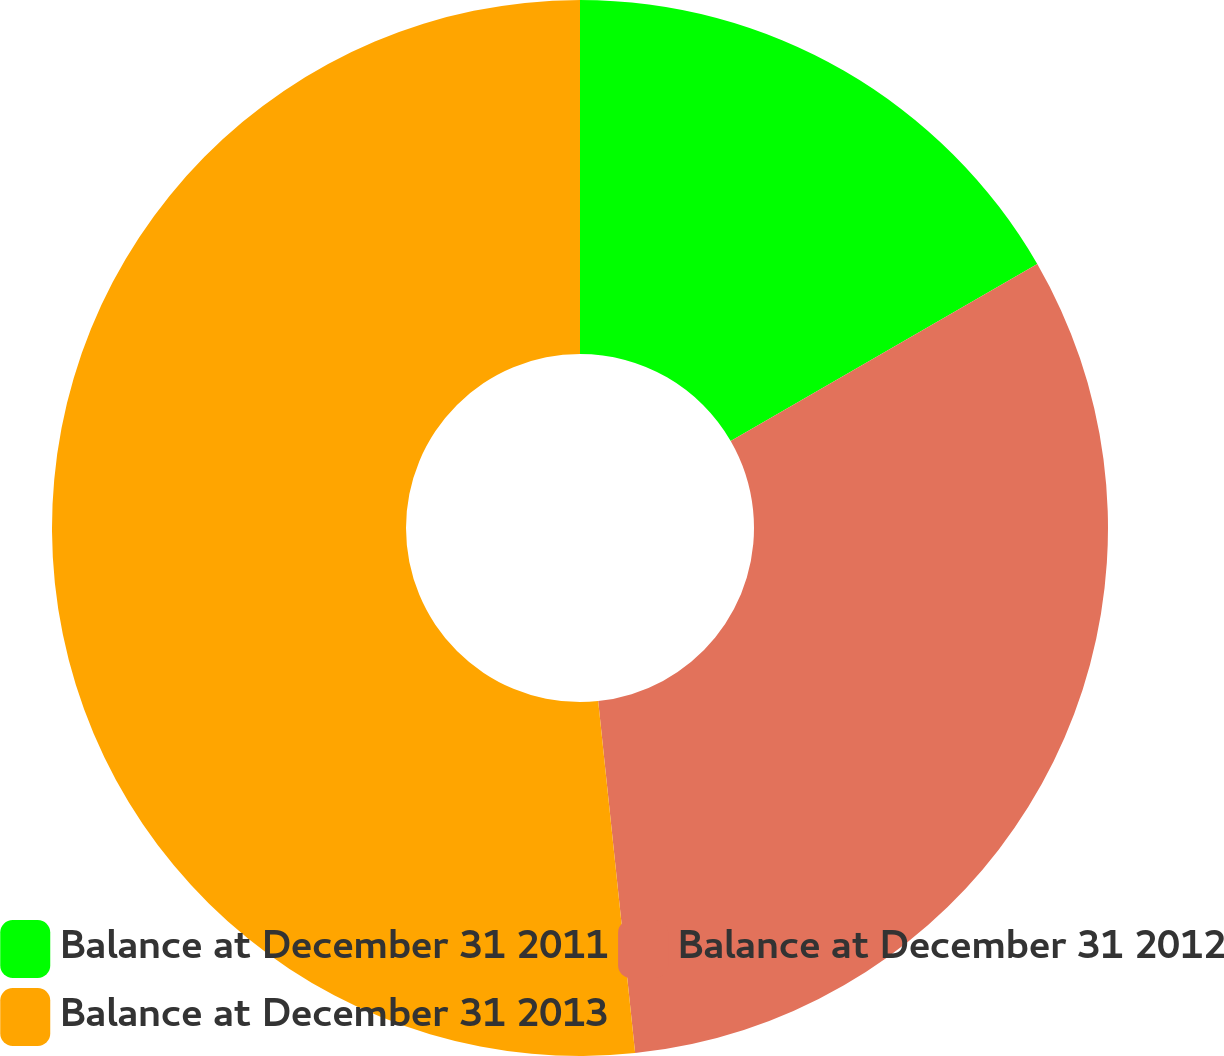Convert chart to OTSL. <chart><loc_0><loc_0><loc_500><loc_500><pie_chart><fcel>Balance at December 31 2011<fcel>Balance at December 31 2012<fcel>Balance at December 31 2013<nl><fcel>16.67%<fcel>31.67%<fcel>51.67%<nl></chart> 